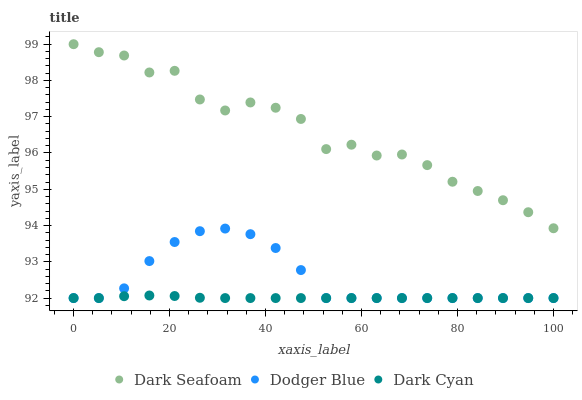Does Dark Cyan have the minimum area under the curve?
Answer yes or no. Yes. Does Dark Seafoam have the maximum area under the curve?
Answer yes or no. Yes. Does Dodger Blue have the minimum area under the curve?
Answer yes or no. No. Does Dodger Blue have the maximum area under the curve?
Answer yes or no. No. Is Dark Cyan the smoothest?
Answer yes or no. Yes. Is Dark Seafoam the roughest?
Answer yes or no. Yes. Is Dodger Blue the smoothest?
Answer yes or no. No. Is Dodger Blue the roughest?
Answer yes or no. No. Does Dark Cyan have the lowest value?
Answer yes or no. Yes. Does Dark Seafoam have the lowest value?
Answer yes or no. No. Does Dark Seafoam have the highest value?
Answer yes or no. Yes. Does Dodger Blue have the highest value?
Answer yes or no. No. Is Dodger Blue less than Dark Seafoam?
Answer yes or no. Yes. Is Dark Seafoam greater than Dodger Blue?
Answer yes or no. Yes. Does Dark Cyan intersect Dodger Blue?
Answer yes or no. Yes. Is Dark Cyan less than Dodger Blue?
Answer yes or no. No. Is Dark Cyan greater than Dodger Blue?
Answer yes or no. No. Does Dodger Blue intersect Dark Seafoam?
Answer yes or no. No. 